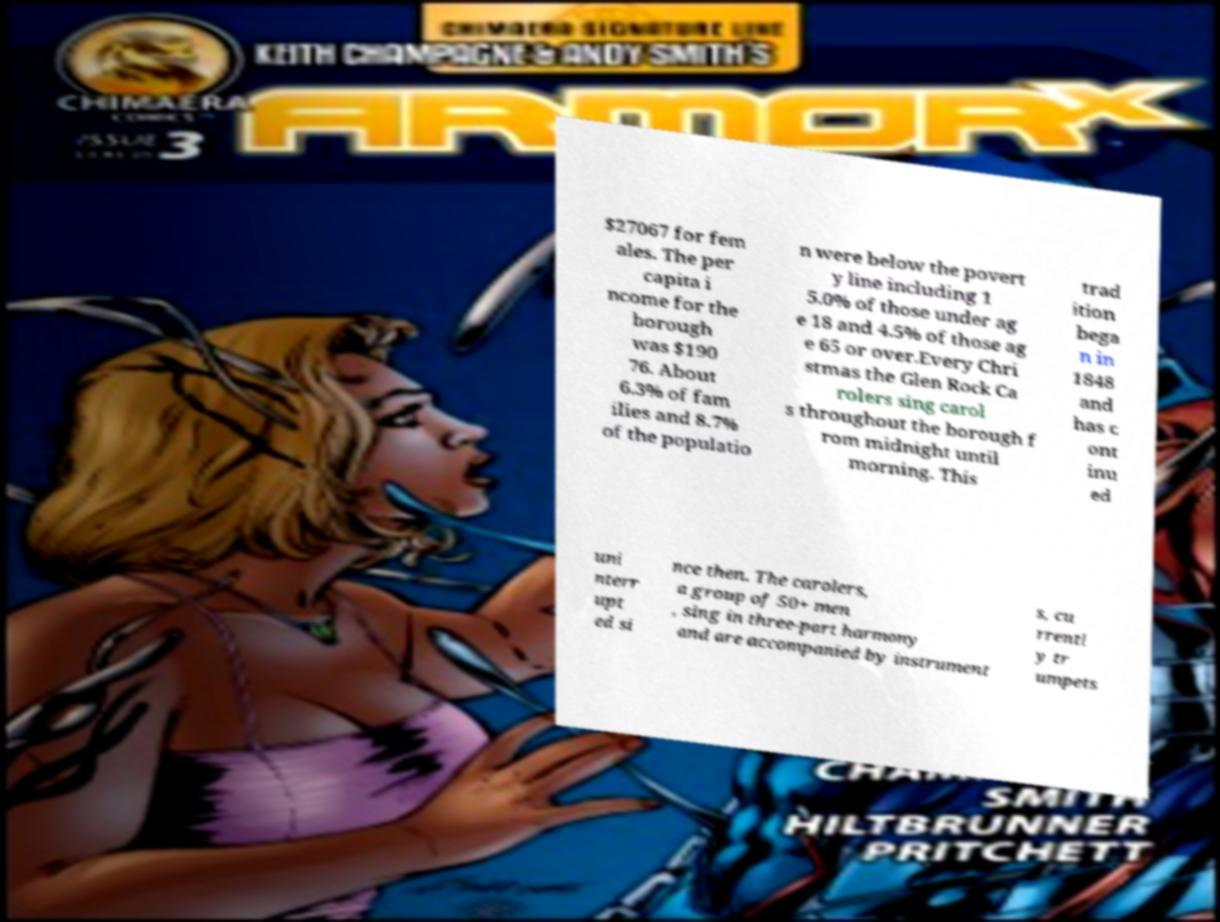For documentation purposes, I need the text within this image transcribed. Could you provide that? $27067 for fem ales. The per capita i ncome for the borough was $190 76. About 6.3% of fam ilies and 8.7% of the populatio n were below the povert y line including 1 5.0% of those under ag e 18 and 4.5% of those ag e 65 or over.Every Chri stmas the Glen Rock Ca rolers sing carol s throughout the borough f rom midnight until morning. This trad ition bega n in 1848 and has c ont inu ed uni nterr upt ed si nce then. The carolers, a group of 50+ men , sing in three-part harmony and are accompanied by instrument s, cu rrentl y tr umpets 